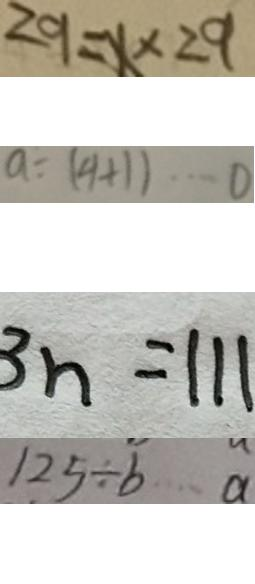Convert formula to latex. <formula><loc_0><loc_0><loc_500><loc_500>2 9 = x \times 2 9 
 a \div ( 9 + 1 ) \cdots 0 
 3 n = 1 1 1 
 1 2 5 \div b \cdots a</formula> 